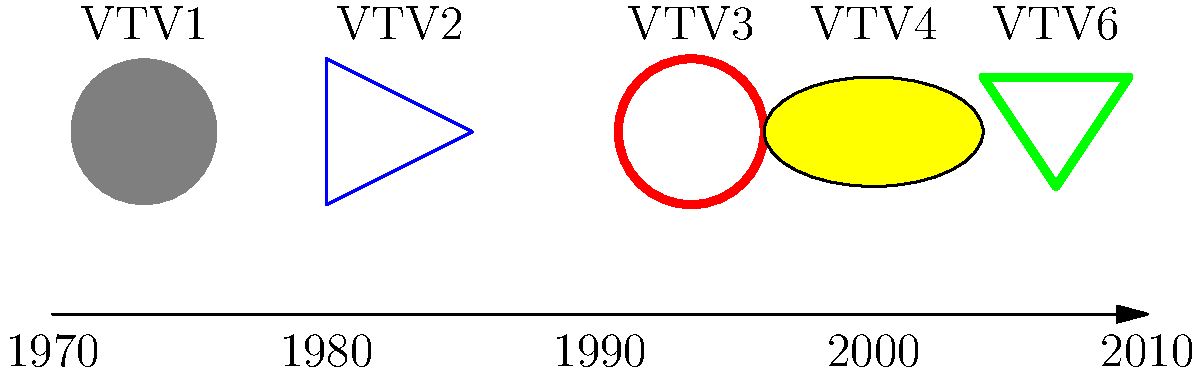Analyze the timeline of Vietnamese television logo designs shown above. Which design element appears to be most consistently used across different periods, and what might this suggest about the branding strategy of Vietnamese television networks? To answer this question, we need to examine the visual elements of each logo representation on the timeline:

1. 1970s (VTV1): A simple gray circle, representing a basic, minimalist design.
2. 1980s (VTV2): A blue triangle, introducing angular shapes.
3. 1990s (VTV3): A red circle outline, returning to circular forms but with less weight.
4. 2000s (VTV4): A yellow ellipse with a black outline, combining circular and oval shapes.
5. 2010s (VTV6): A green triangle, reintroducing angular shapes.

Analyzing these designs, we can observe that:

1. Circular shapes appear in three out of five logos (VTV1, VTV3, and VTV4).
2. Triangular shapes appear in two logos (VTV2 and VTV6).
3. Colors vary across all logos, suggesting no consistent color scheme.
4. Simplicity is maintained throughout, with each logo using basic geometric shapes.

The most consistently used design element across different periods is the use of basic geometric shapes, particularly circular forms. This suggests that Vietnamese television networks have maintained a strategy of using simple, recognizable shapes in their branding.

The consistent use of geometric shapes, especially circles, might indicate:
1. A desire for visual continuity and brand recognition over time.
2. An emphasis on unity and completeness, often associated with circular shapes.
3. A preference for designs that are easy to reproduce across various media.

This branding strategy suggests that Vietnamese television networks prioritize simplicity, recognizability, and adaptability in their logo designs while allowing for some variation and modernization over time.
Answer: Basic geometric shapes, especially circular forms 